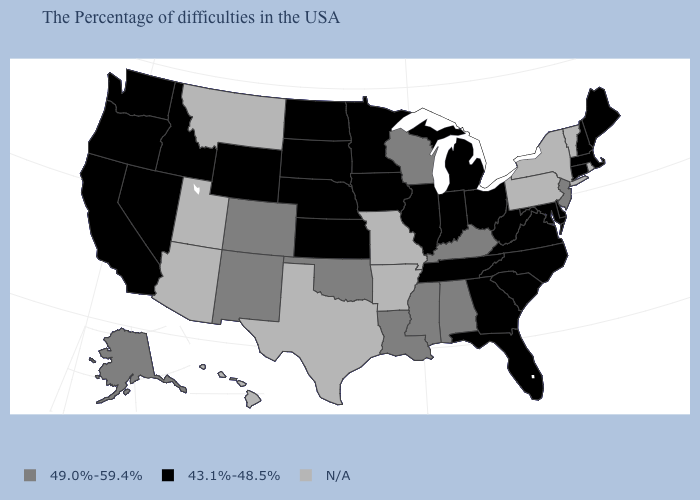Name the states that have a value in the range N/A?
Give a very brief answer. Rhode Island, Vermont, New York, Pennsylvania, Missouri, Arkansas, Texas, Utah, Montana, Arizona, Hawaii. What is the value of Kansas?
Give a very brief answer. 43.1%-48.5%. What is the value of Utah?
Give a very brief answer. N/A. Does the map have missing data?
Write a very short answer. Yes. Name the states that have a value in the range N/A?
Write a very short answer. Rhode Island, Vermont, New York, Pennsylvania, Missouri, Arkansas, Texas, Utah, Montana, Arizona, Hawaii. What is the lowest value in the MidWest?
Concise answer only. 43.1%-48.5%. How many symbols are there in the legend?
Quick response, please. 3. What is the highest value in the South ?
Give a very brief answer. 49.0%-59.4%. What is the value of Hawaii?
Short answer required. N/A. Does Minnesota have the highest value in the USA?
Answer briefly. No. Name the states that have a value in the range N/A?
Keep it brief. Rhode Island, Vermont, New York, Pennsylvania, Missouri, Arkansas, Texas, Utah, Montana, Arizona, Hawaii. What is the value of Pennsylvania?
Short answer required. N/A. 